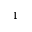<formula> <loc_0><loc_0><loc_500><loc_500>^ { 1 }</formula> 